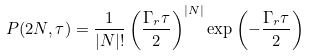Convert formula to latex. <formula><loc_0><loc_0><loc_500><loc_500>P ( 2 N , \tau ) = \frac { 1 } { | N | ! } \left ( \frac { \Gamma _ { r } \tau } { 2 } \right ) ^ { | N | } \exp \left ( - \frac { \Gamma _ { r } \tau } { 2 } \right )</formula> 